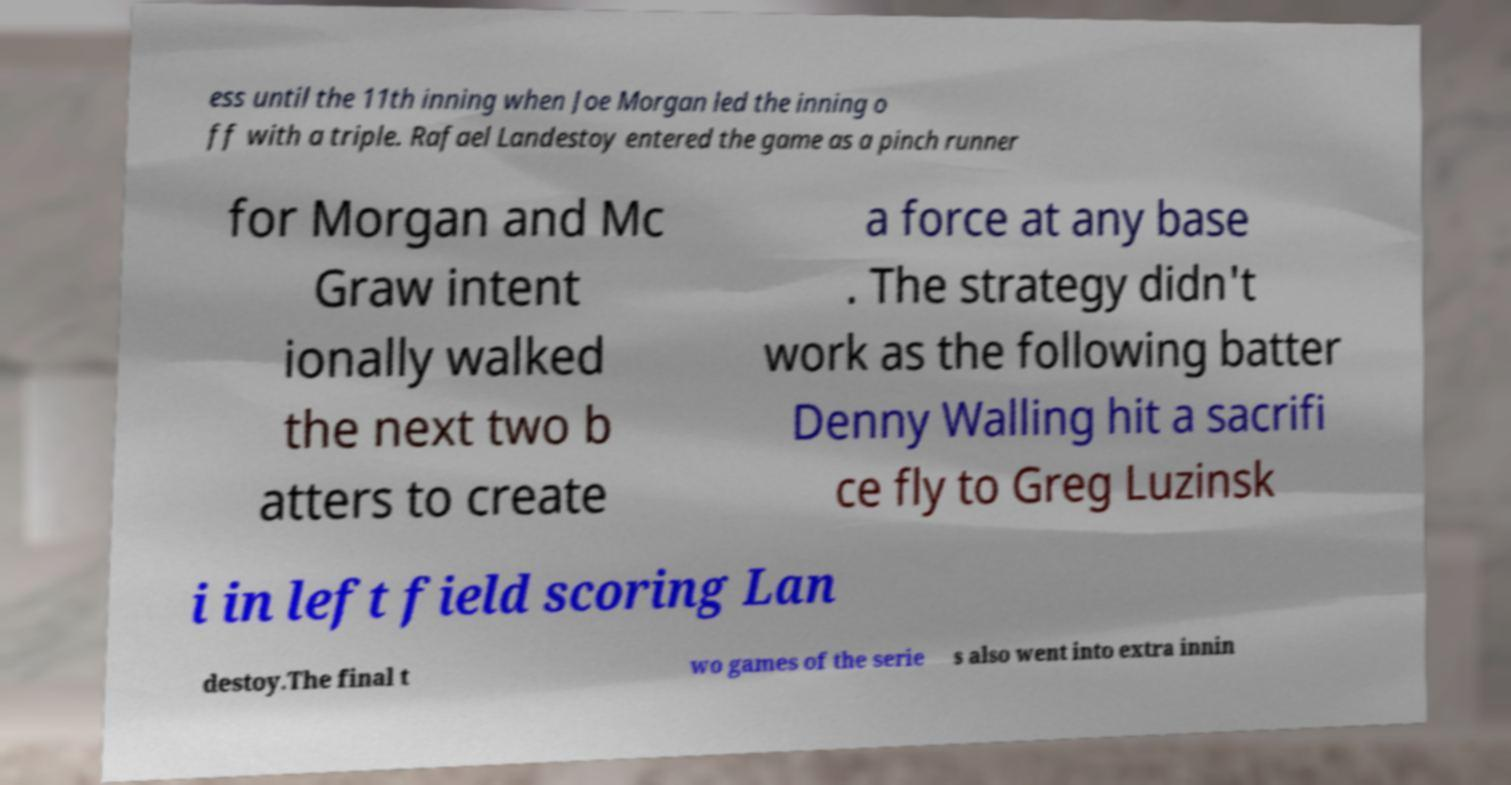Could you extract and type out the text from this image? ess until the 11th inning when Joe Morgan led the inning o ff with a triple. Rafael Landestoy entered the game as a pinch runner for Morgan and Mc Graw intent ionally walked the next two b atters to create a force at any base . The strategy didn't work as the following batter Denny Walling hit a sacrifi ce fly to Greg Luzinsk i in left field scoring Lan destoy.The final t wo games of the serie s also went into extra innin 